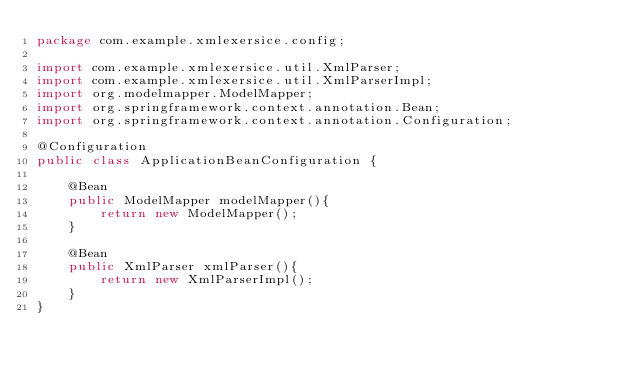Convert code to text. <code><loc_0><loc_0><loc_500><loc_500><_Java_>package com.example.xmlexersice.config;

import com.example.xmlexersice.util.XmlParser;
import com.example.xmlexersice.util.XmlParserImpl;
import org.modelmapper.ModelMapper;
import org.springframework.context.annotation.Bean;
import org.springframework.context.annotation.Configuration;

@Configuration
public class ApplicationBeanConfiguration {

    @Bean
    public ModelMapper modelMapper(){
        return new ModelMapper();
    }

    @Bean
    public XmlParser xmlParser(){
        return new XmlParserImpl();
    }
}
</code> 